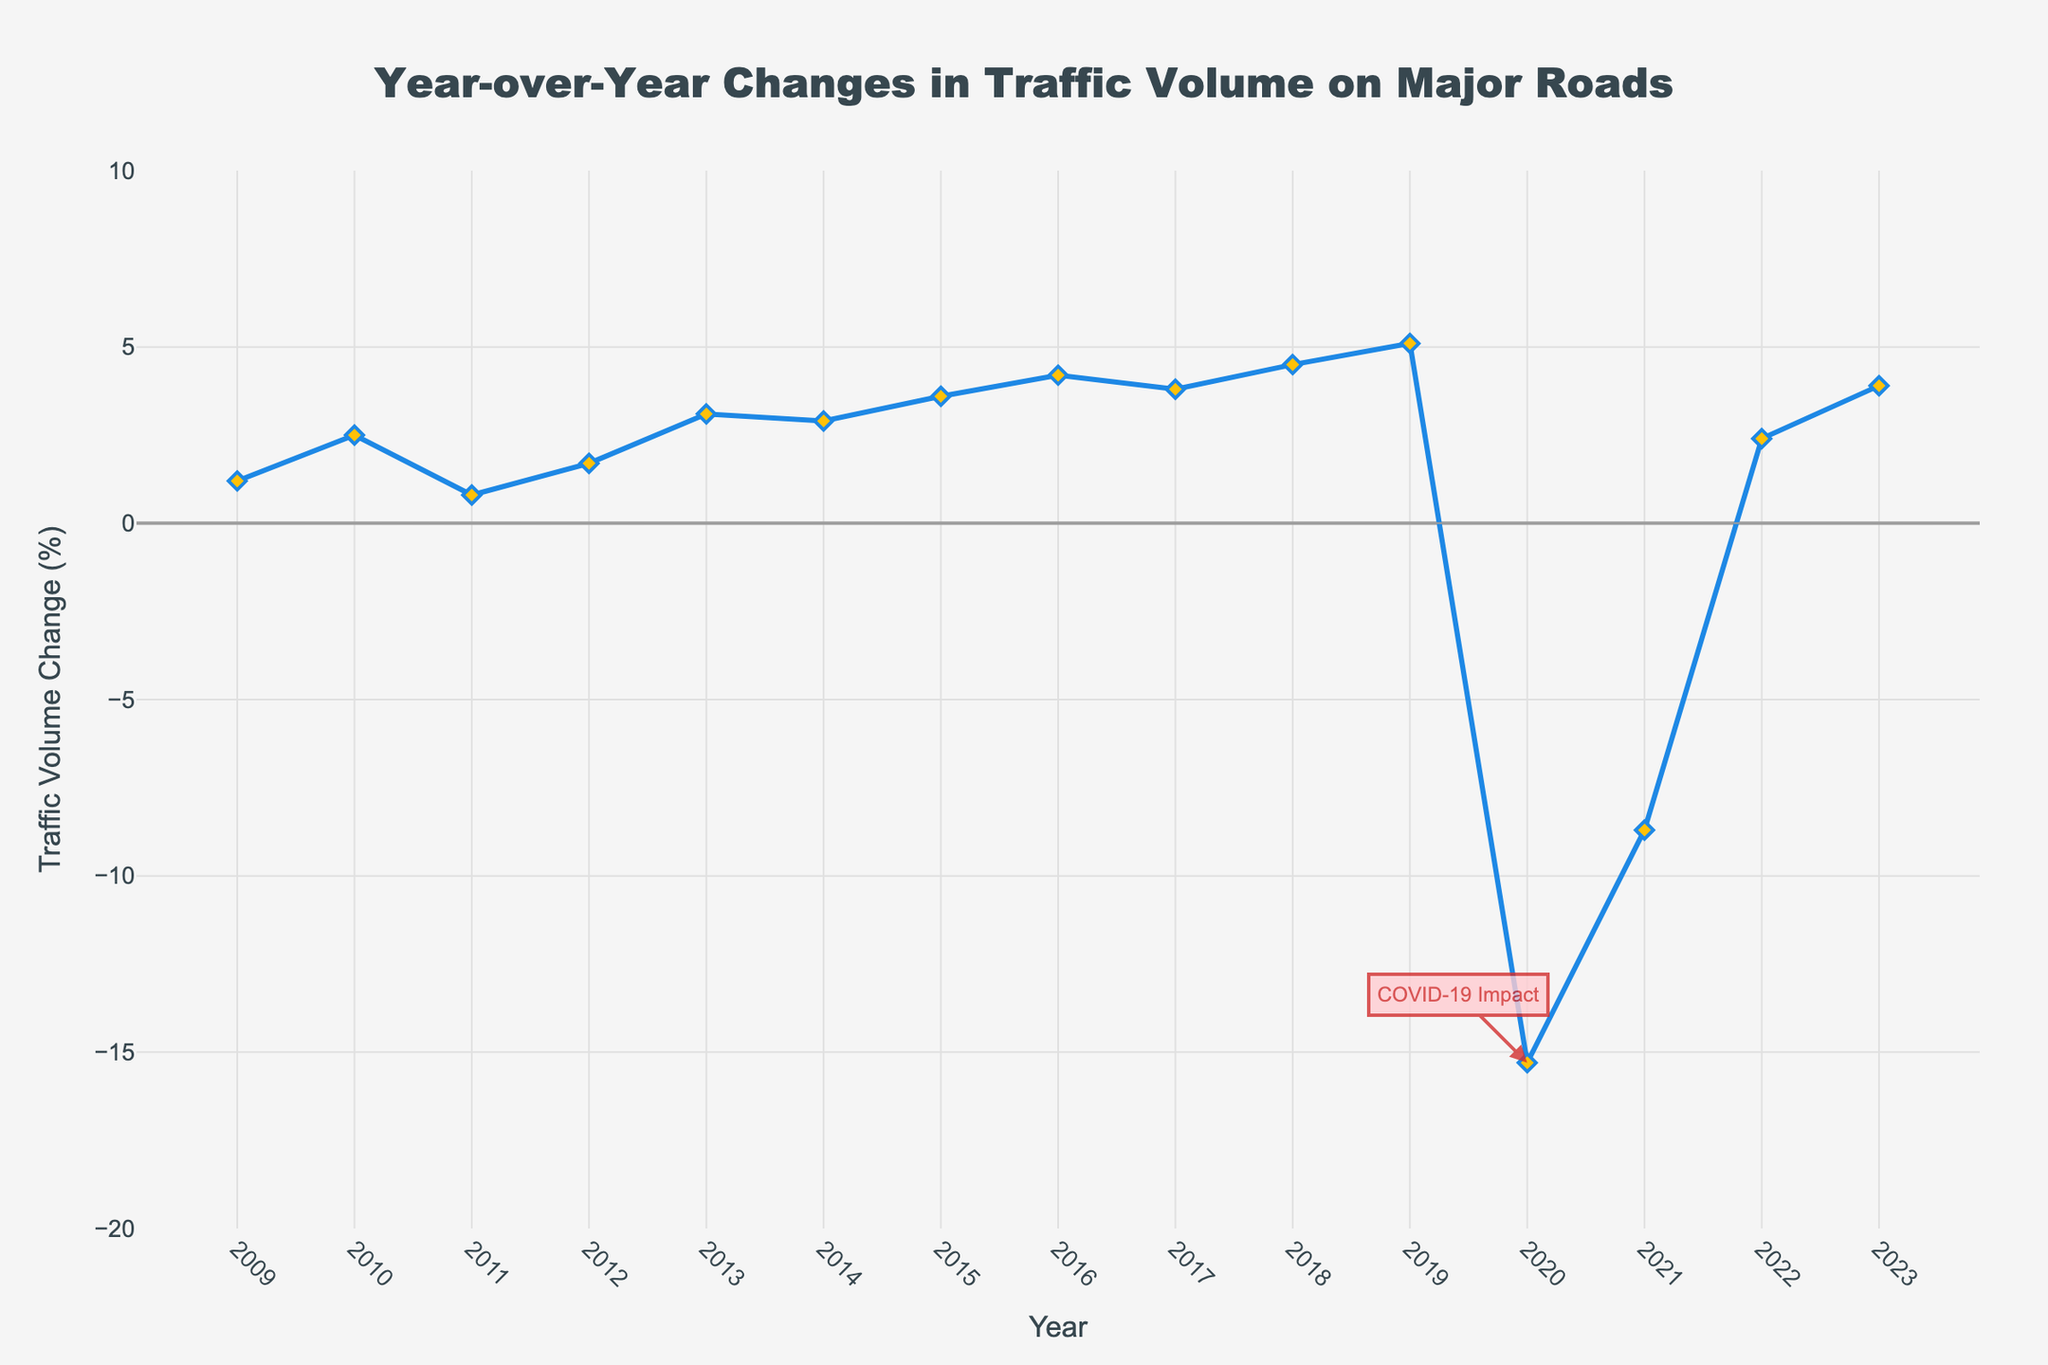What was the percentage change in traffic volume in 2013? To find the percentage change in traffic volume in 2013, look directly at the value plotted for the year 2013 on the line chart.
Answer: 3.1% Which year saw the highest decrease in traffic volume during peak hours? Identify the point on the chart where the line dips to the lowest value. This corresponds to the largest decrease in traffic volume.
Answer: 2020 How did the traffic volume change between 2020 and 2021? Look at the traffic volume change values for both 2020 and 2021. Calculate the difference: -8.7% - (-15.3%) = 6.6%. 2021 saw an increase of 6.6 percentage points compared to 2020.
Answer: Increase by 6.6 percentage points On average, how did the traffic volume change from 2009 to 2019? Sum the percentage changes from 2009 to 2019 and divide by the number of years: (1.2 + 2.5 + 0.8 + 1.7 + 3.1 + 2.9 + 3.6 + 4.2 + 3.8 + 4.5 + 5.1) / 11 = 3.22%.
Answer: 3.22% Which year experienced the first substantial negative impact on traffic volume, and how is it annotated? Find the year where the line first drops significantly below 0, indicating a negative change, and check any annotations on the chart. The chart is annotated with “COVID-19 Impact” at 2020.
Answer: 2020, COVID-19 Impact What is the overall trend of traffic volume changes from 2009 to 2023? Observe the general direction of the line from the start to the end of the chart. The trend is increasing overall but has a significant dip during 2020 and 2021.
Answer: Increasing Compare the traffic volume change in 2015 to 2022. Which year had a higher percentage change and by how much? Look at the percentages for 2015 and 2022 and find the difference: 3.6% - 2.4% = 1.2%.
Answer: 2015, by 1.2 percentage points How many years saw a positive change in traffic volume? Count the number of years where the line is above 0. Years: 2009-2019, 2022-2023, so 13 years.
Answer: 13 years What is the median change in traffic volume from 2009 to 2019? Arrange the annual changes from 2009 to 2019 in order and find the middle value. The sorted changes are 0.8, 1.2, 1.7, 2.5, 2.9, 3.1, 3.6, 3.8, 4.2, 4.5, 5.1. The median is the 6th value: 3.1%.
Answer: 3.1% What was the year-over-year difference in traffic volume change between 2019 and 2020? Calculate the difference: -15.3% - 5.1% = -20.4%. The traffic volume decreased by 20.4 percentage points from 2019 to 2020.
Answer: Decrease by 20.4 percentage points 